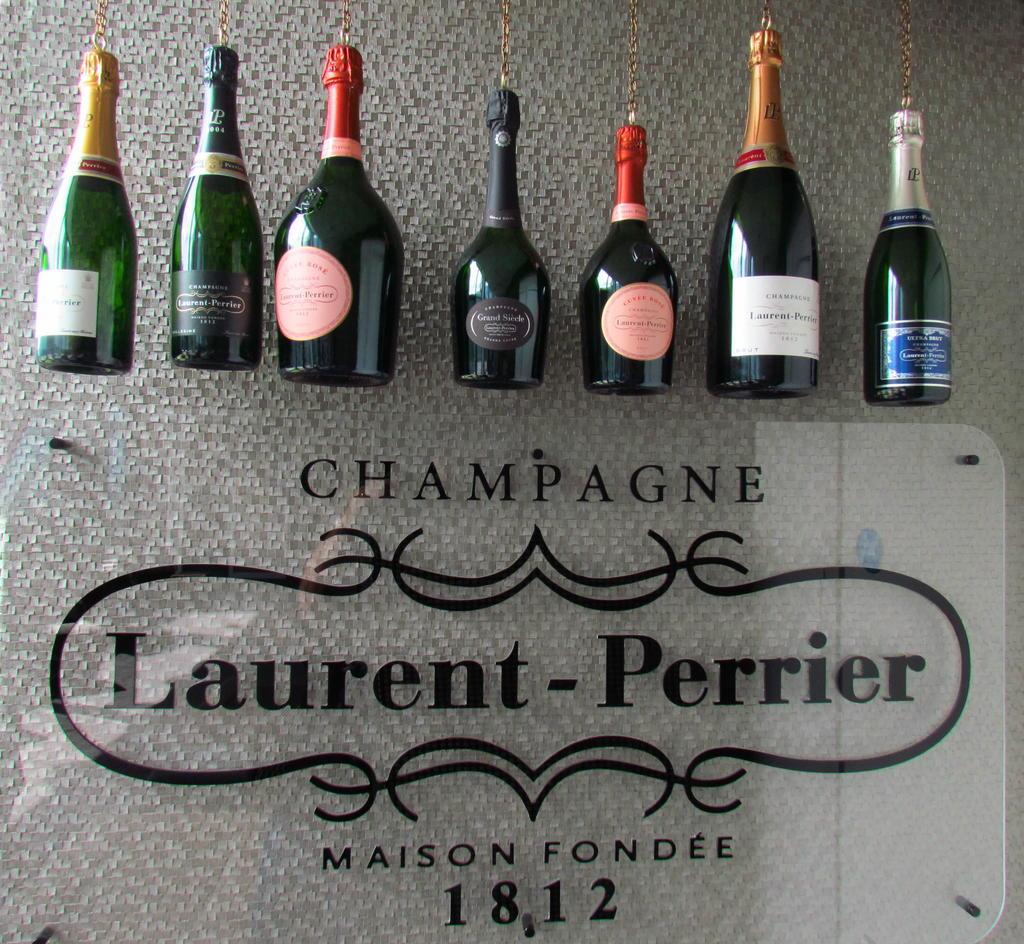Whats the year this champagne was founded in?
Give a very brief answer. 1812. 